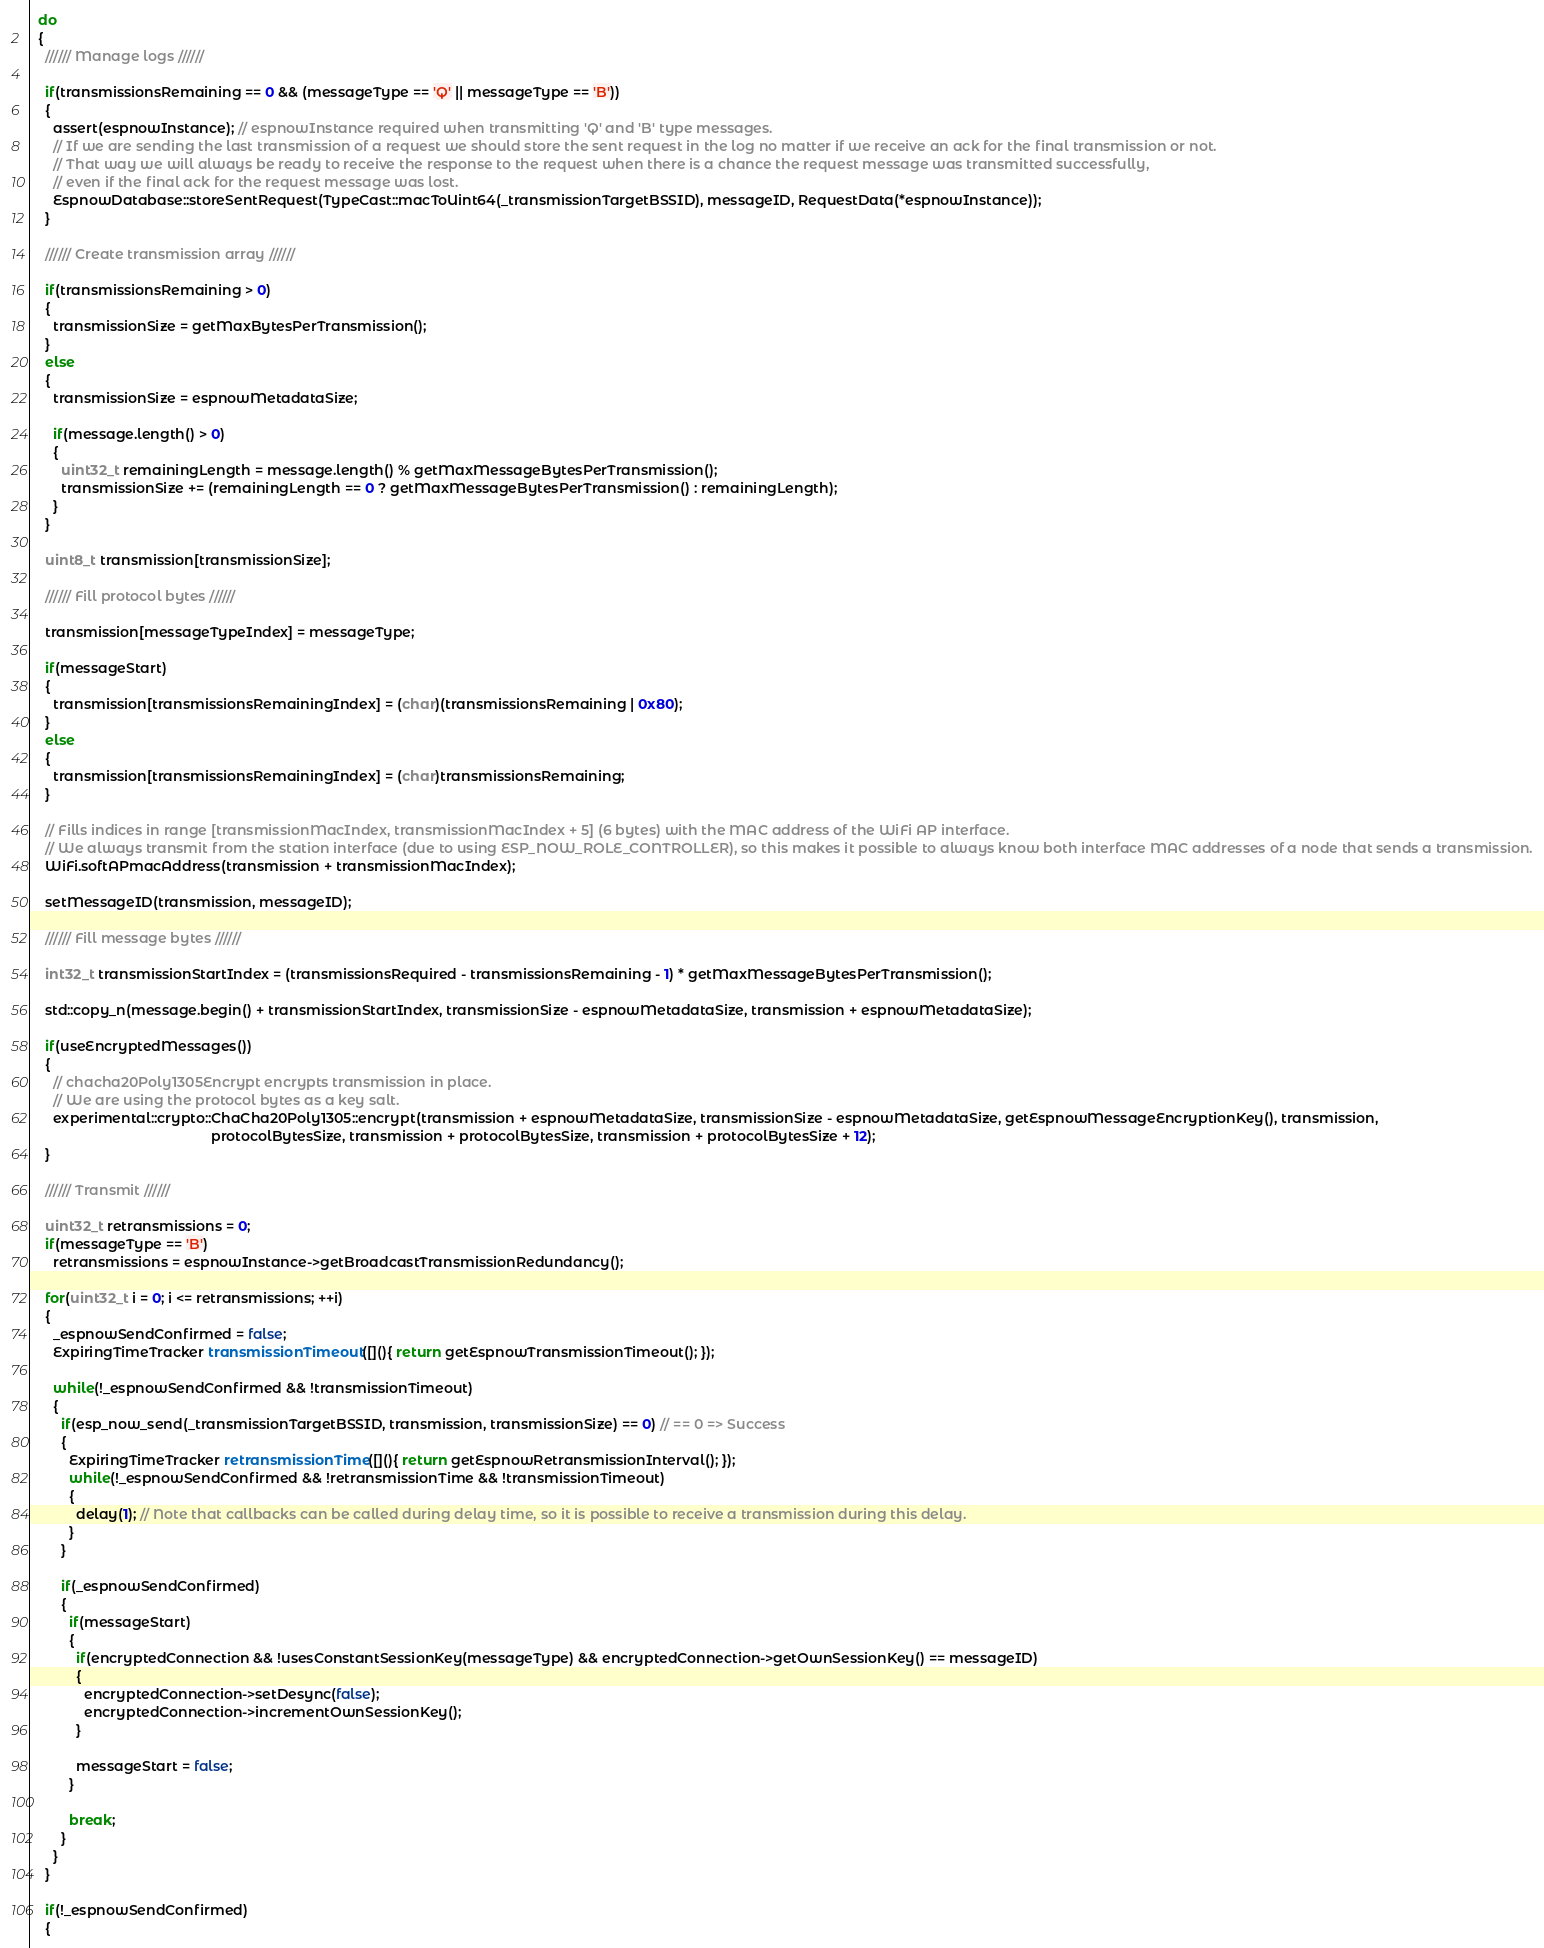<code> <loc_0><loc_0><loc_500><loc_500><_C++_>
  do
  {
    ////// Manage logs //////
    
    if(transmissionsRemaining == 0 && (messageType == 'Q' || messageType == 'B'))
    {
      assert(espnowInstance); // espnowInstance required when transmitting 'Q' and 'B' type messages.
      // If we are sending the last transmission of a request we should store the sent request in the log no matter if we receive an ack for the final transmission or not.
      // That way we will always be ready to receive the response to the request when there is a chance the request message was transmitted successfully, 
      // even if the final ack for the request message was lost.
      EspnowDatabase::storeSentRequest(TypeCast::macToUint64(_transmissionTargetBSSID), messageID, RequestData(*espnowInstance));
    }
    
    ////// Create transmission array //////
    
    if(transmissionsRemaining > 0)
    {
      transmissionSize = getMaxBytesPerTransmission();
    }
    else
    {
      transmissionSize = espnowMetadataSize;
      
      if(message.length() > 0)
      {
        uint32_t remainingLength = message.length() % getMaxMessageBytesPerTransmission();
        transmissionSize += (remainingLength == 0 ? getMaxMessageBytesPerTransmission() : remainingLength);
      }
    }
    
    uint8_t transmission[transmissionSize];

    ////// Fill protocol bytes //////
    
    transmission[messageTypeIndex] = messageType;
    
    if(messageStart)
    {
      transmission[transmissionsRemainingIndex] = (char)(transmissionsRemaining | 0x80);
    }
    else
    {
      transmission[transmissionsRemainingIndex] = (char)transmissionsRemaining;
    }

    // Fills indices in range [transmissionMacIndex, transmissionMacIndex + 5] (6 bytes) with the MAC address of the WiFi AP interface.
    // We always transmit from the station interface (due to using ESP_NOW_ROLE_CONTROLLER), so this makes it possible to always know both interface MAC addresses of a node that sends a transmission.
    WiFi.softAPmacAddress(transmission + transmissionMacIndex);

    setMessageID(transmission, messageID);

    ////// Fill message bytes //////
    
    int32_t transmissionStartIndex = (transmissionsRequired - transmissionsRemaining - 1) * getMaxMessageBytesPerTransmission();
    
    std::copy_n(message.begin() + transmissionStartIndex, transmissionSize - espnowMetadataSize, transmission + espnowMetadataSize);

    if(useEncryptedMessages())
    {      
      // chacha20Poly1305Encrypt encrypts transmission in place.
      // We are using the protocol bytes as a key salt.
      experimental::crypto::ChaCha20Poly1305::encrypt(transmission + espnowMetadataSize, transmissionSize - espnowMetadataSize, getEspnowMessageEncryptionKey(), transmission, 
                                               protocolBytesSize, transmission + protocolBytesSize, transmission + protocolBytesSize + 12);
    }
    
    ////// Transmit //////

    uint32_t retransmissions = 0;
    if(messageType == 'B')
      retransmissions = espnowInstance->getBroadcastTransmissionRedundancy();
      
    for(uint32_t i = 0; i <= retransmissions; ++i)
    {
      _espnowSendConfirmed = false;
      ExpiringTimeTracker transmissionTimeout([](){ return getEspnowTransmissionTimeout(); });
      
      while(!_espnowSendConfirmed && !transmissionTimeout)
      {
        if(esp_now_send(_transmissionTargetBSSID, transmission, transmissionSize) == 0) // == 0 => Success
        {
          ExpiringTimeTracker retransmissionTime([](){ return getEspnowRetransmissionInterval(); });
          while(!_espnowSendConfirmed && !retransmissionTime && !transmissionTimeout)
          {        
            delay(1); // Note that callbacks can be called during delay time, so it is possible to receive a transmission during this delay.
          }
        }
  
        if(_espnowSendConfirmed)
        {
          if(messageStart)
          {        
            if(encryptedConnection && !usesConstantSessionKey(messageType) && encryptedConnection->getOwnSessionKey() == messageID)
            {
              encryptedConnection->setDesync(false);
              encryptedConnection->incrementOwnSessionKey();
            }
            
            messageStart = false;
          }  
          
          break;
        }
      }
    }
    
    if(!_espnowSendConfirmed)
    {</code> 